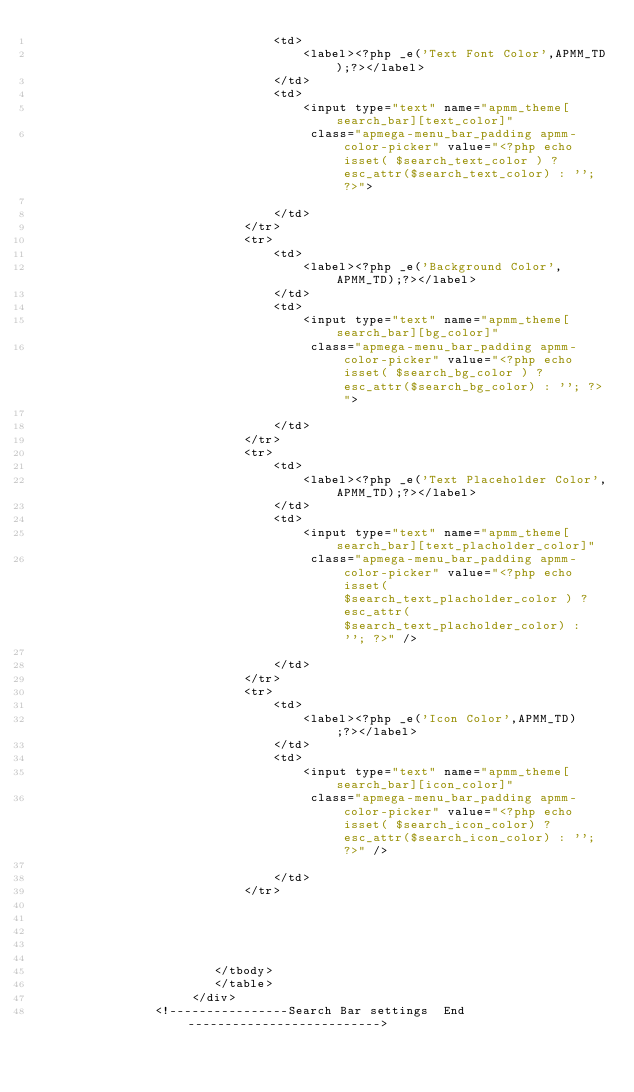<code> <loc_0><loc_0><loc_500><loc_500><_PHP_>								<td>
									<label><?php _e('Text Font Color',APMM_TD);?></label>
								</td>
								<td>
									<input type="text" name="apmm_theme[search_bar][text_color]" 
								     class="apmega-menu_bar_padding apmm-color-picker" value="<?php echo isset( $search_text_color ) ? esc_attr($search_text_color) : ''; ?>">
							 
								</td>
							</tr>
							<tr>
								<td>
									<label><?php _e('Background Color',APMM_TD);?></label>
								</td>
								<td>
									<input type="text" name="apmm_theme[search_bar][bg_color]" 
								     class="apmega-menu_bar_padding apmm-color-picker" value="<?php echo isset( $search_bg_color ) ? esc_attr($search_bg_color) : ''; ?>">
							 
								</td>
							</tr>
							<tr>
								<td>
									<label><?php _e('Text Placeholder Color',APMM_TD);?></label>
								</td>
								<td>
									<input type="text" name="apmm_theme[search_bar][text_placholder_color]" 
								     class="apmega-menu_bar_padding apmm-color-picker" value="<?php echo isset( $search_text_placholder_color ) ? esc_attr($search_text_placholder_color) : ''; ?>" />
							 
								</td>
							</tr>
							<tr>
								<td>
									<label><?php _e('Icon Color',APMM_TD);?></label>
								</td>
								<td>
									<input type="text" name="apmm_theme[search_bar][icon_color]" 
								     class="apmega-menu_bar_padding apmm-color-picker" value="<?php echo isset( $search_icon_color) ? esc_attr($search_icon_color) : ''; ?>" />
							 
								</td>
							</tr>
							
							
							
							
					
						</tbody>
						</table>
		             </div>
                <!----------------Search Bar settings  End--------------------------></code> 